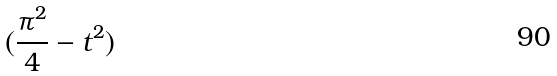<formula> <loc_0><loc_0><loc_500><loc_500>( \frac { \pi ^ { 2 } } { 4 } - t ^ { 2 } )</formula> 